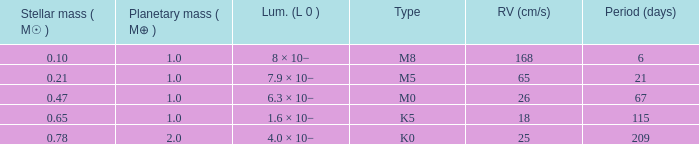What is the highest planetary mass having an RV (cm/s) of 65 and a Period (days) less than 21? None. 